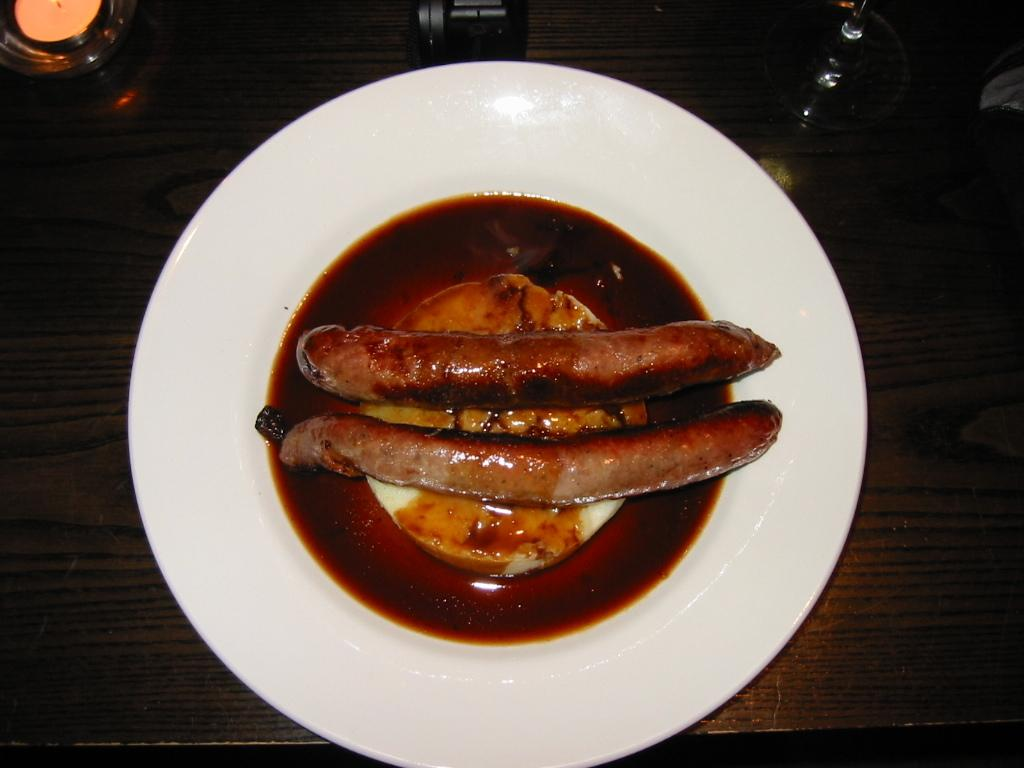What is on the plate that is visible in the image? There is a plate with food in the image. What is the plate placed on? The plate is on a wooden table. What is beside the plate on the table? There is a glass and a candle beside the plate. What type of grain is being harvested in the image? There is no indication of any grain or harvesting in the image; it features a plate with food on a wooden table. 